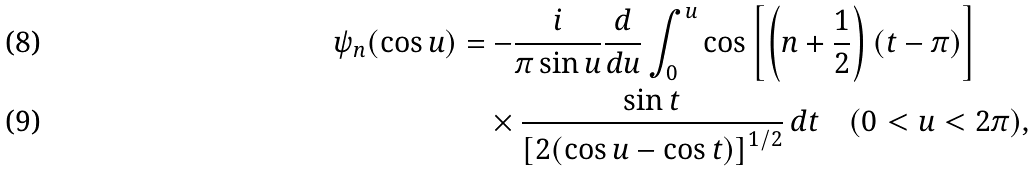<formula> <loc_0><loc_0><loc_500><loc_500>\psi _ { n } ( \cos u ) & = - \frac { i } { \pi \sin u } \frac { d } { d u } \int _ { 0 } ^ { u } \cos \left [ \left ( n + \frac { 1 } { 2 } \right ) ( t - \pi ) \right ] \\ & \quad \times \frac { \sin t } { \left [ 2 ( \cos u - \cos t ) \right ] ^ { 1 / 2 } } \, d t \quad ( 0 < u < 2 \pi ) ,</formula> 